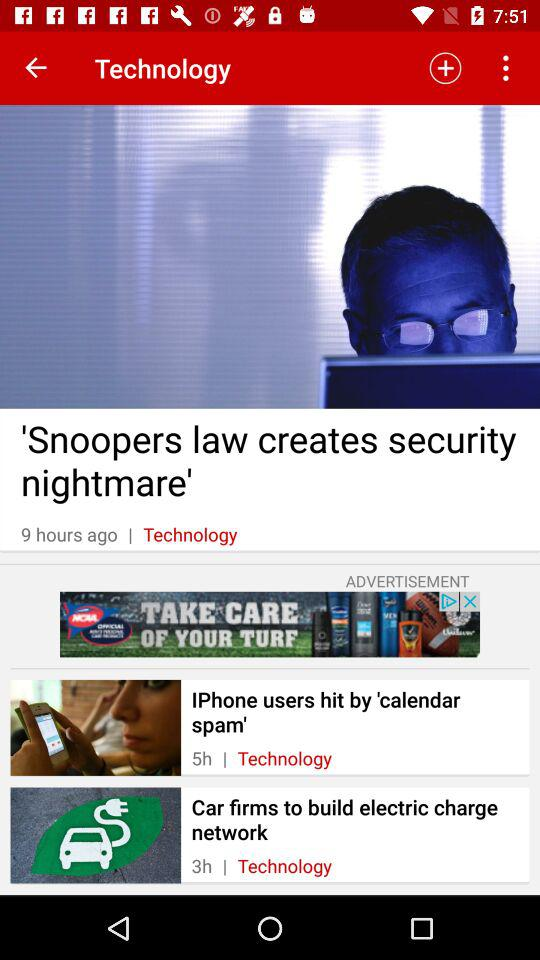How many hours ago was the article about the snoopers law published?
Answer the question using a single word or phrase. 9 